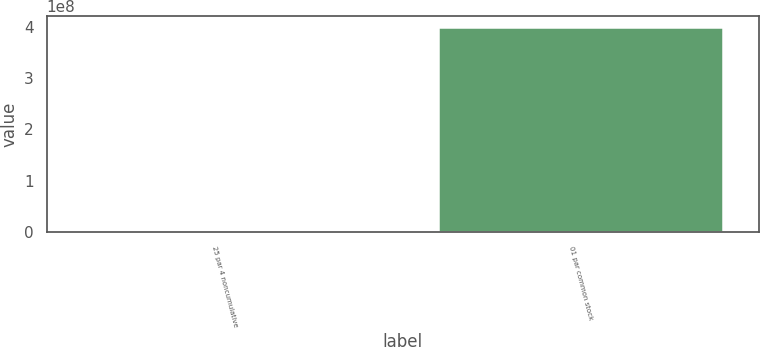<chart> <loc_0><loc_0><loc_500><loc_500><bar_chart><fcel>25 par 4 noncumulative<fcel>01 par common stock<nl><fcel>840000<fcel>4e+08<nl></chart> 